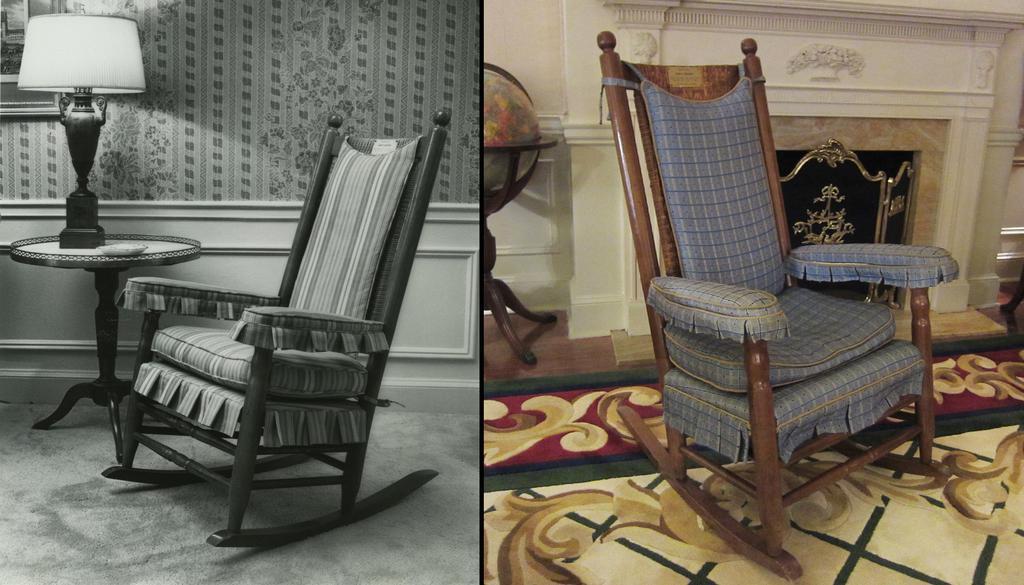Please provide a concise description of this image. This is a collage image. In this image we can see the black and white image of the same as in the color image. In the image we can see chair, bed lamp on the side table, fireplace and a decor. 